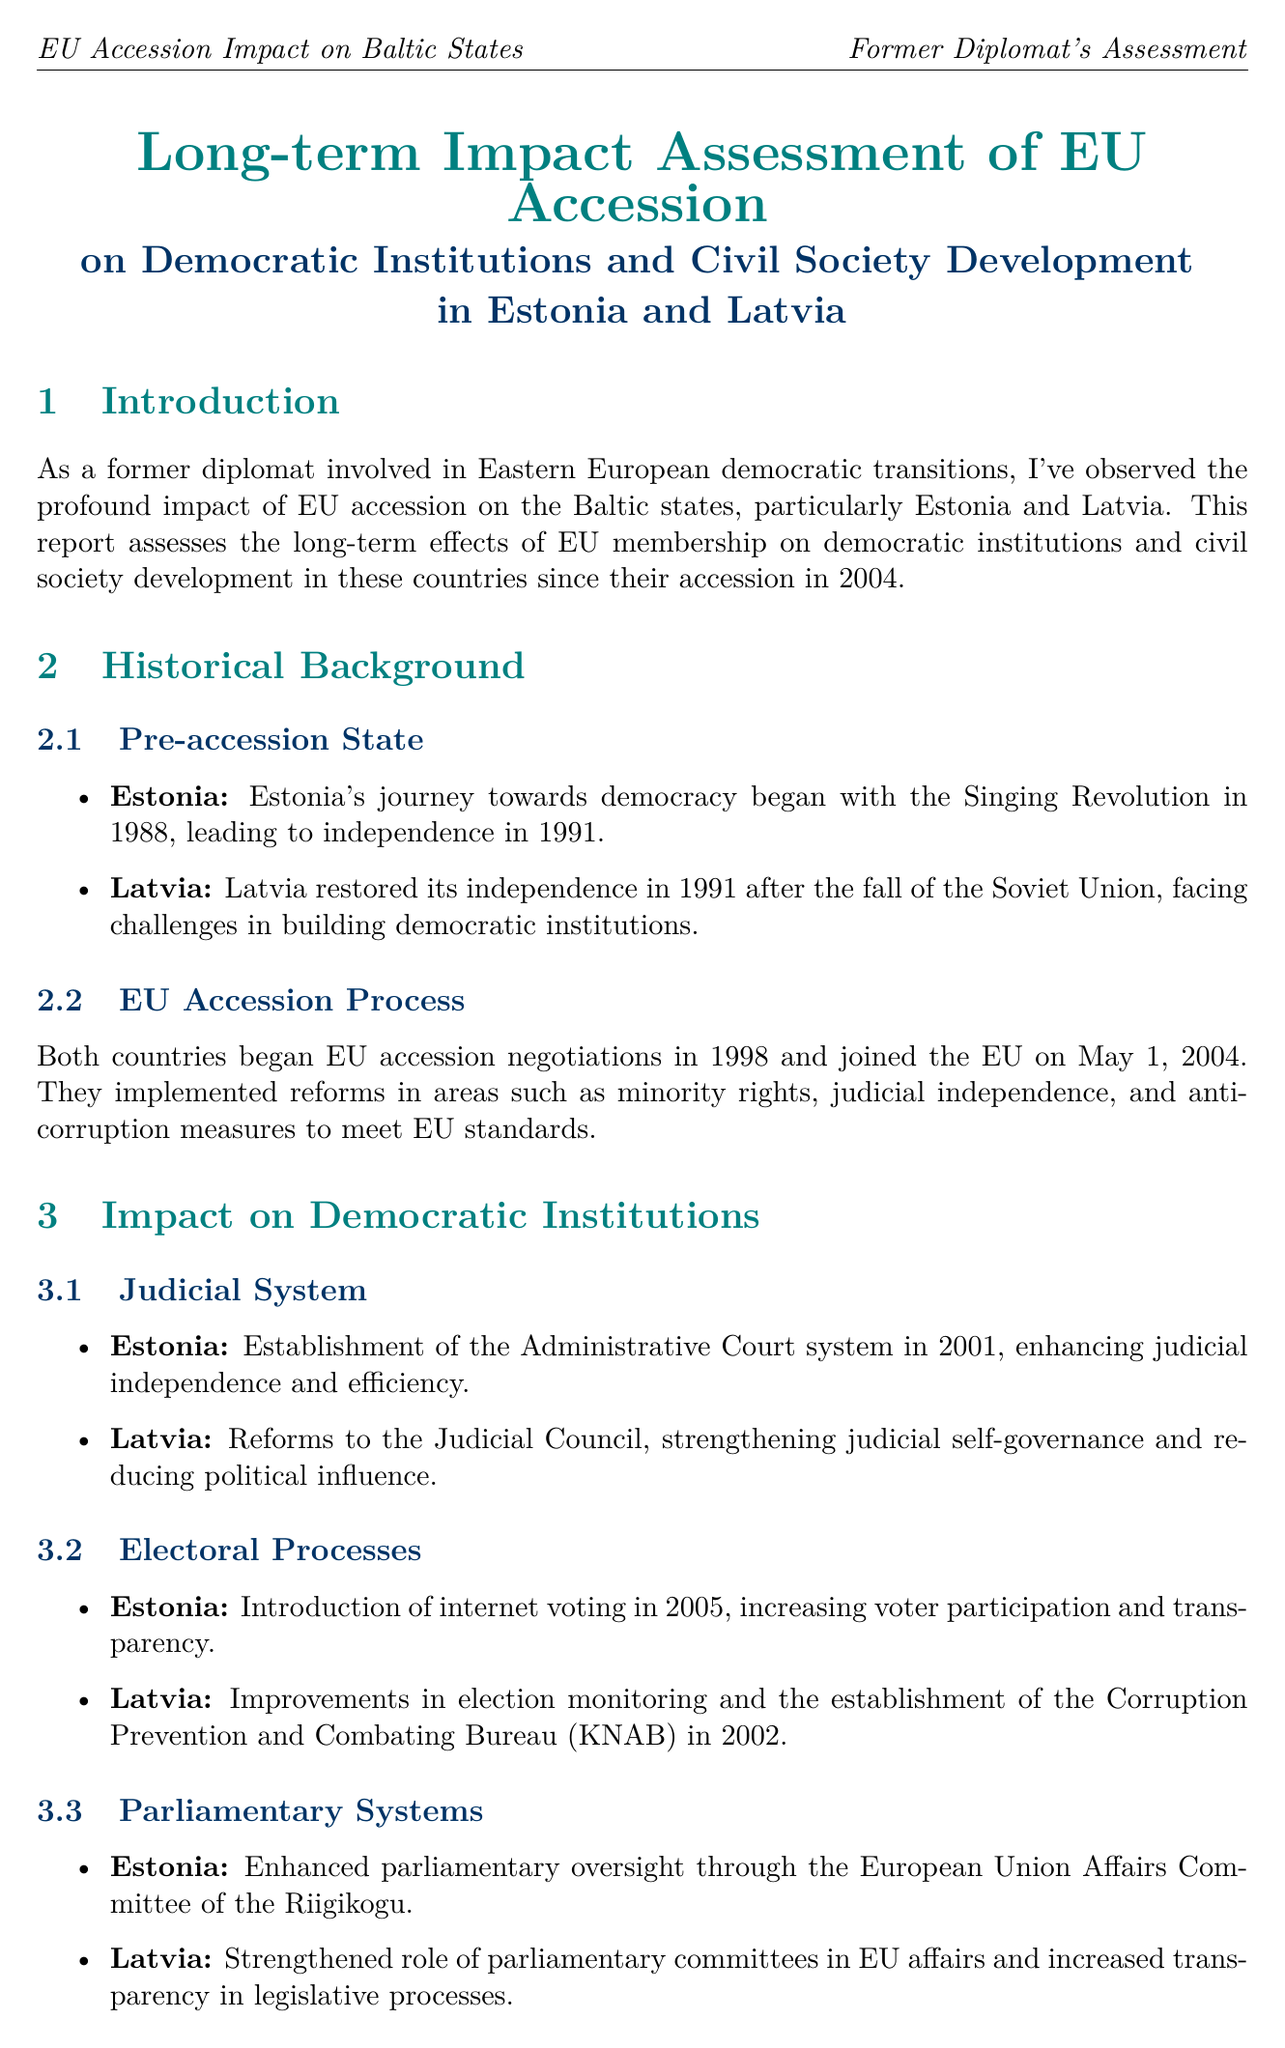What year did Estonia and Latvia join the EU? The document states that both countries joined the EU on May 1, 2004.
Answer: May 1, 2004 How many NGOs were there in Estonia in 2004? The report mentions that there were 15,000 NGOs in Estonia in 2004.
Answer: 15,000 What significant reform was introduced in Estonia in 2005? The introduction of internet voting in 2005 is highlighted as a significant reform in Estonia.
Answer: Internet voting What is the name of the public participation platform introduced in Latvia? The document references "ManaBalss.lv" as the public participation platform introduced in Latvia in 2011.
Answer: ManaBalss.lv What ongoing challenge is highlighted in both Estonia and Latvia? The report addresses "minority integration" as an ongoing challenge in both countries.
Answer: Minority integration What year was the NGO Fund established in Latvia? The establishment of the NGO Fund in Latvia occurred in 2007, according to the document.
Answer: 2007 What is emphasized as crucial for further consolidation of democratic gains? The conclusion mentions that "continued engagement with EU mechanisms and values" is crucial for further consolidation.
Answer: Continued engagement with EU mechanisms and values Which country's judiciary reforms strengthened judicial self-governance? The report points out that Latvia's reforms to the Judicial Council strengthened judicial self-governance.
Answer: Latvia What key area did both countries implement reforms in to meet EU standards? The document states that both countries implemented reforms in "minority rights" to meet EU standards.
Answer: Minority rights 